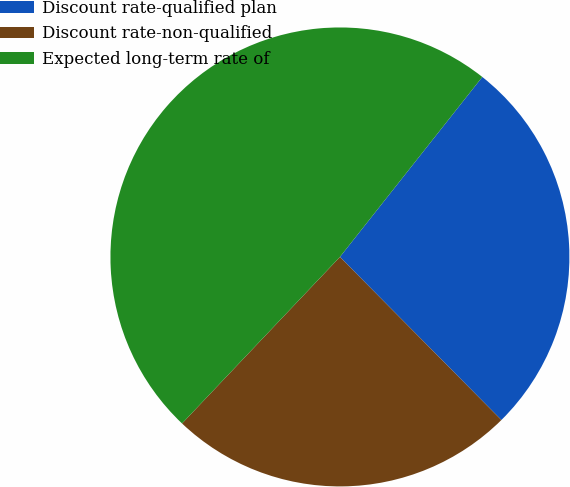<chart> <loc_0><loc_0><loc_500><loc_500><pie_chart><fcel>Discount rate-qualified plan<fcel>Discount rate-non-qualified<fcel>Expected long-term rate of<nl><fcel>26.93%<fcel>24.5%<fcel>48.58%<nl></chart> 